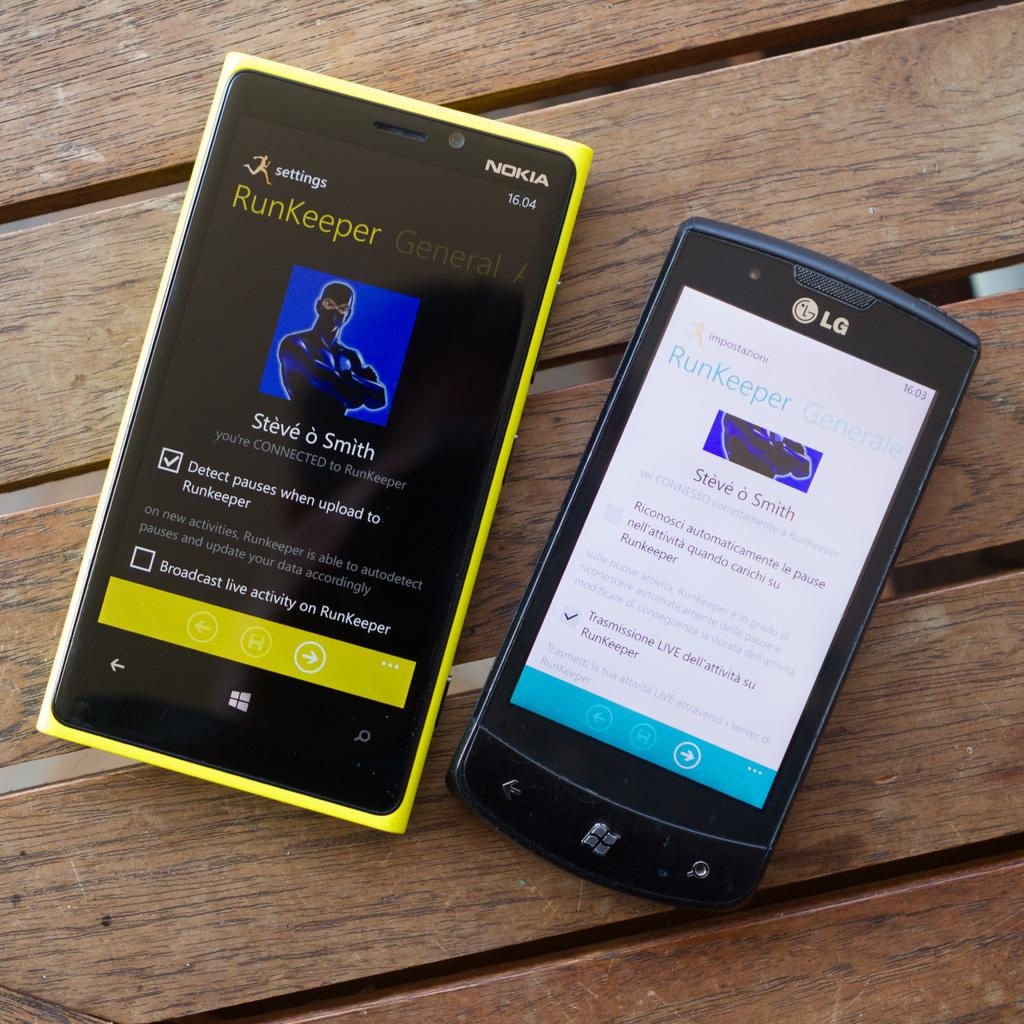<image>
Give a short and clear explanation of the subsequent image. Nokia and LG phones display the RunKeeper app. 